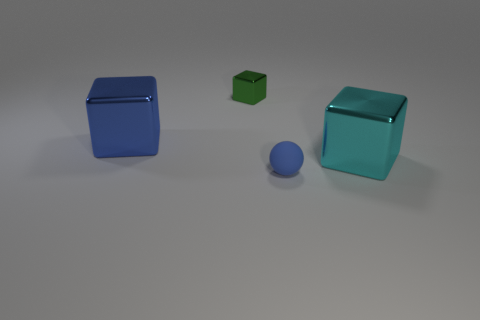Subtract all big shiny cubes. How many cubes are left? 1 Subtract all cubes. How many objects are left? 1 Add 4 big blue cylinders. How many objects exist? 8 Add 1 matte spheres. How many matte spheres are left? 2 Add 3 large blue metallic cubes. How many large blue metallic cubes exist? 4 Subtract 0 brown cubes. How many objects are left? 4 Subtract all brown metallic objects. Subtract all blue shiny cubes. How many objects are left? 3 